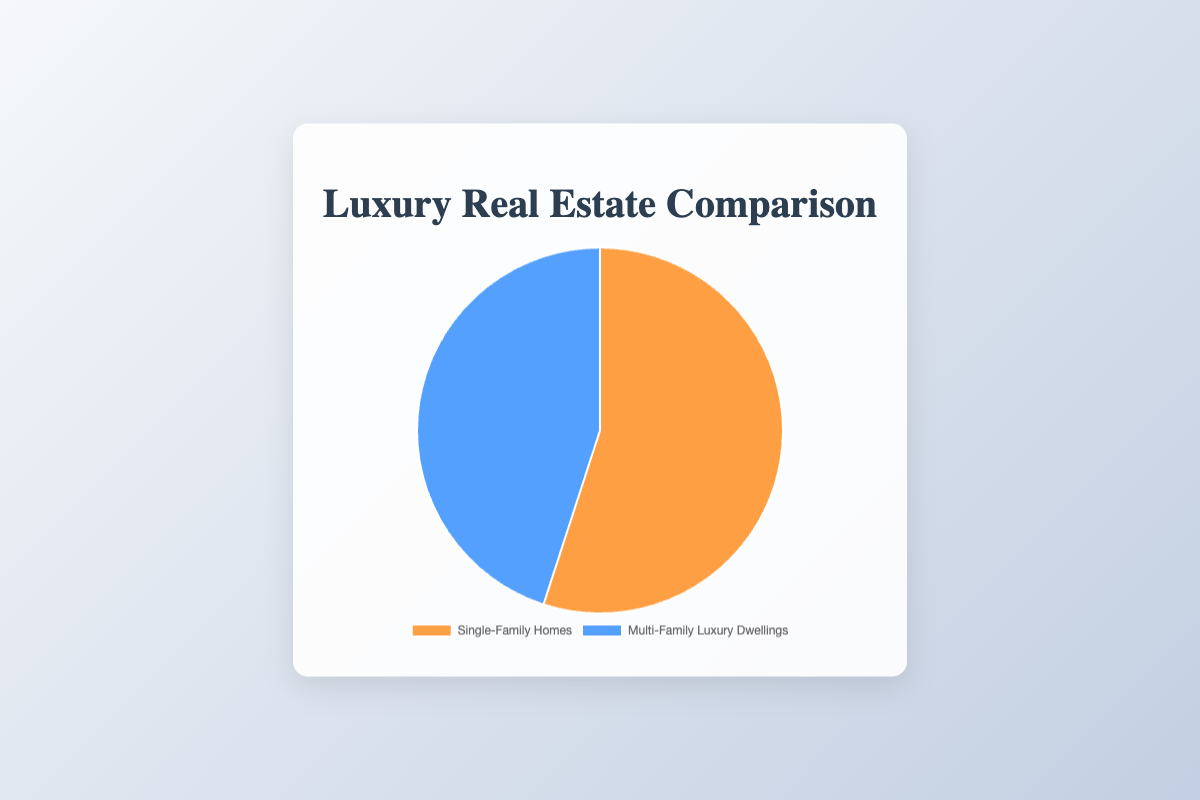what percentage of the chart represents single-family homes? The single-family homes category comprises 55% of the total pie chart. This is directly indicated by the chart's data label.
Answer: 55% How much do multi-family luxury dwellings contribute to the total percentage? Multi-family luxury dwellings make up 45% of the total, as indicated by the chart's data label.
Answer: 45% Which category has a greater share, single-family homes or multi-family luxury dwellings? Comparing the two data points, single-family homes have a greater share at 55%, while multi-family luxury dwellings have 45%.
Answer: Single-family homes What is the difference in percentage between single-family homes and multi-family luxury dwellings? The difference is calculated as 55% (single-family homes) - 45% (multi-family luxury dwellings), resulting in 10%.
Answer: 10% If you combine both categories, what is the total percentage represented in the pie chart? Summing 55% (single-family homes) and 45% (multi-family luxury dwellings) equals 100%.
Answer: 100% Describe the color representing multi-family luxury dwellings in the pie chart. The section representing multi-family luxury dwellings is shaded in blue.
Answer: blue Describe the color used for single-family homes in the pie chart. The section representing single-family homes is shaded in orange.
Answer: orange What is the sum of the percentages of single-family homes and multi-family luxury dwellings? Adding the two percentages together (55% for single-family homes and 45% for multi-family luxury dwellings) results in 100%.
Answer: 100% What percentage represents non-single-family homes in the chart? Non-single-family homes in the chart are represented by multi-family luxury dwellings, which accounts for 45%.
Answer: 45% Is the percentage of multi-family luxury dwellings higher, lower, or equal to half of the total pie chart? The percentage for multi-family luxury dwellings is 45%, which is lower than half of the total pie chart (50%).
Answer: lower 